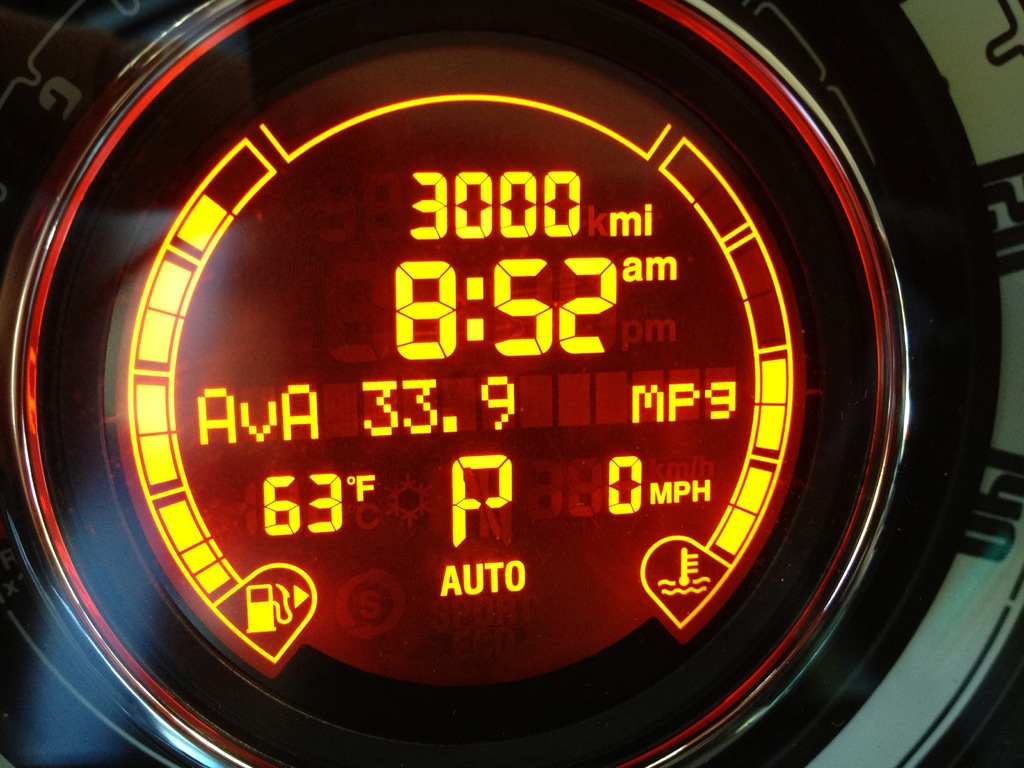Can you explain what the 'P' indicator means on the dashboard? The 'P' on the dashboard stands for 'Park.' It indicates that the car's transmission is set in the park position, which means the vehicle is securely stopped and will not move even if it's on a slope. Is there information on the dashboard about fuel efficiency while the car is parked? The dashboard shows an average fuel efficiency of 33.9 MPG, which typically accounts for overall driving conditions and may not specifically provide statistics for when the car is parked. 